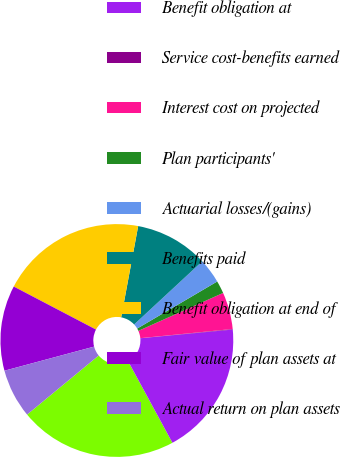Convert chart. <chart><loc_0><loc_0><loc_500><loc_500><pie_chart><fcel>Dollars in Millions<fcel>Benefit obligation at<fcel>Service cost-benefits earned<fcel>Interest cost on projected<fcel>Plan participants'<fcel>Actuarial losses/(gains)<fcel>Benefits paid<fcel>Benefit obligation at end of<fcel>Fair value of plan assets at<fcel>Actual return on plan assets<nl><fcel>21.94%<fcel>18.58%<fcel>0.08%<fcel>5.12%<fcel>1.76%<fcel>3.44%<fcel>10.17%<fcel>20.26%<fcel>11.85%<fcel>6.8%<nl></chart> 